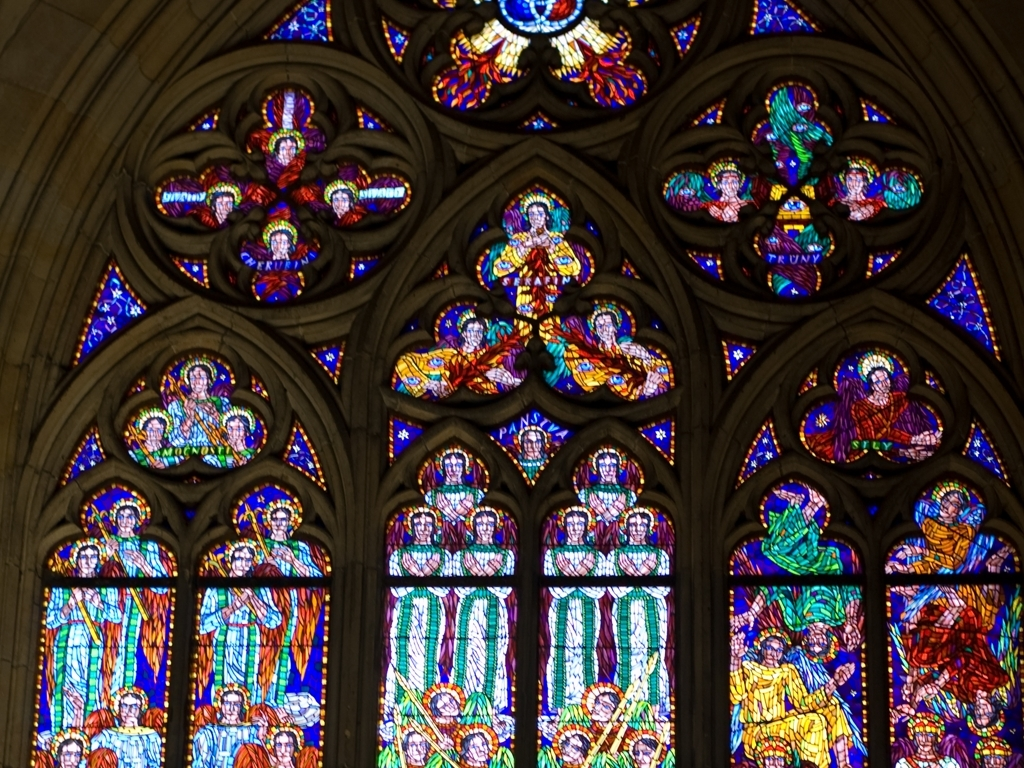How does the color scheme of the stained glass affect the atmosphere or mood of the space? The vibrant blues, reds, and yellows of the stained glass create a rich, luminous quality that bathes the interior in a warm, kaleidoscopic light. This can evoke a sense of wonder, reverence, and tranquility, aligning with the spiritual purpose of the space. Could you tell me more about the techniques used to create the stained glass? Traditional stained glass windows are made by cutting colored glass into specific shapes and fitting them into lead cames to create the design. The pieces are then soldered together and the window is installed in its frame. The technique requires great precision and artistry, as evidenced by the intricate details and patterns seen in the image. 